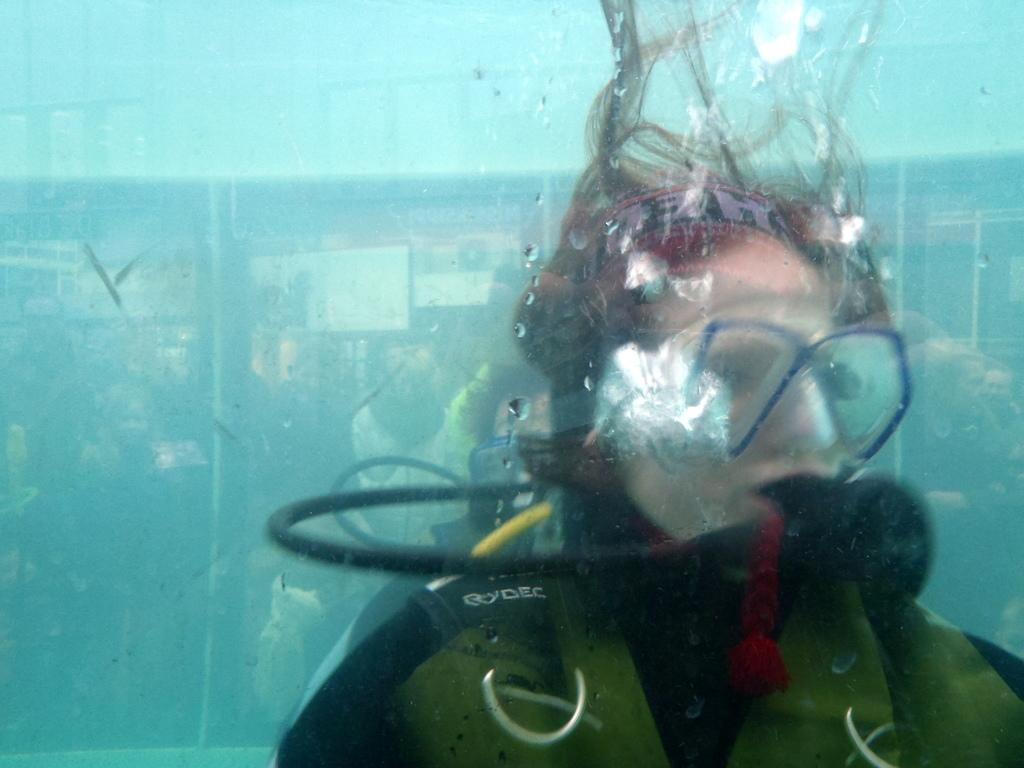What is the person in the water doing? The person in the water is wearing goggles and has an oxygen pipe, which suggests they are likely swimming or diving. What equipment is the person using for breathing underwater? The person has an oxygen pipe for breathing underwater. Can you describe the people visible in the background? There are people visible in the background, but their specific actions or activities cannot be determined from the provided facts. What objects can be seen in the background? There are boards visible in the background. How does the person increase the size of the book they are holding in the image? There is no book present in the image, so it is not possible to answer that question. 